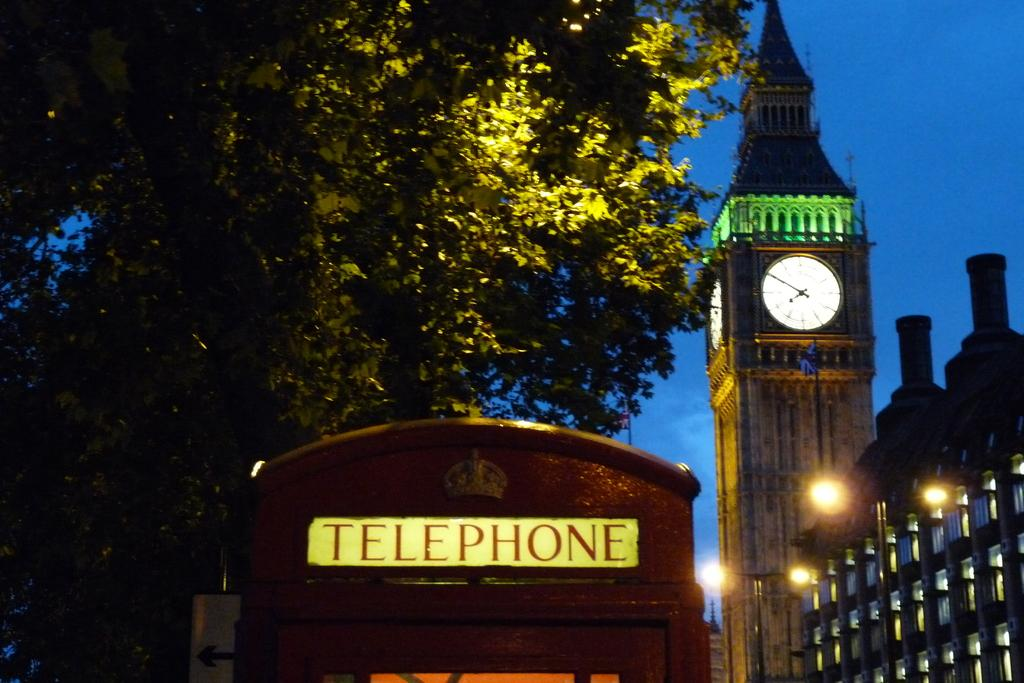<image>
Describe the image concisely. A telephone both is visible at night with a big clock tower next to it. 